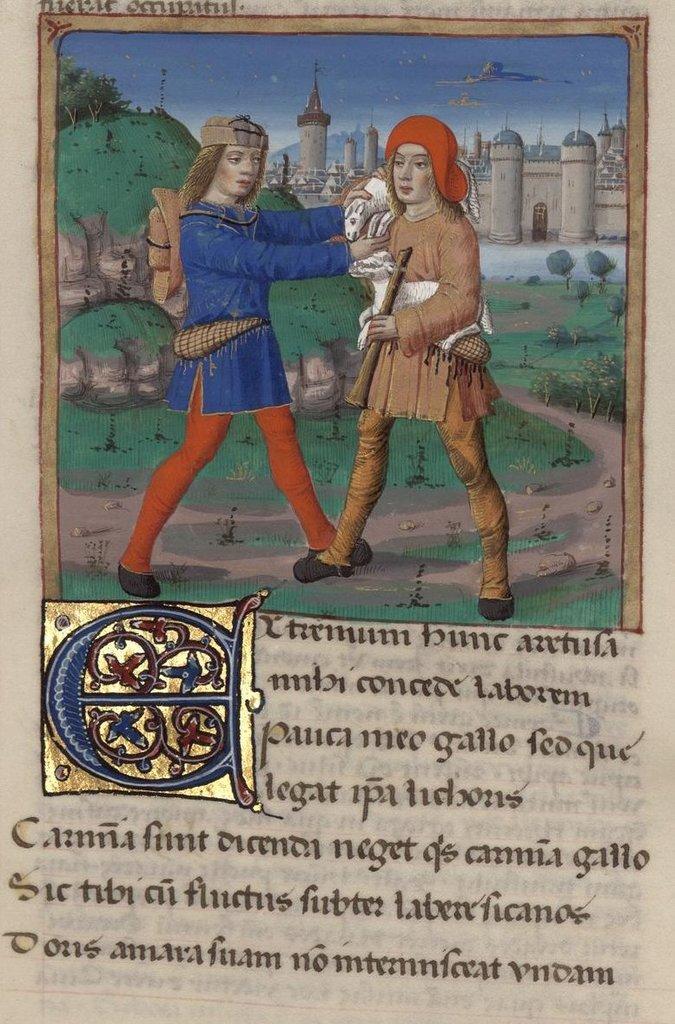In one or two sentences, can you explain what this image depicts? In the image in the center we can see one poster. On poster,we can see sky,clouds,building,wall,trees,plants,grass and two persons were standing and holding some objects and we can see something written on it. 